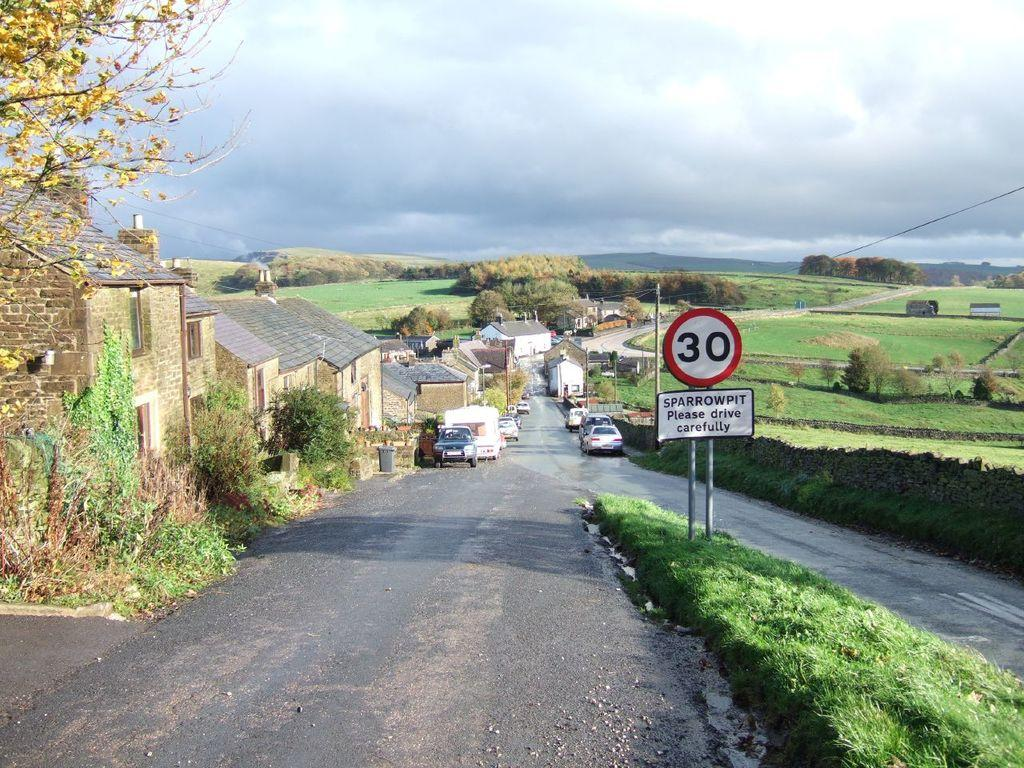<image>
Summarize the visual content of the image. A street with a sign that has the number 30 on it. 